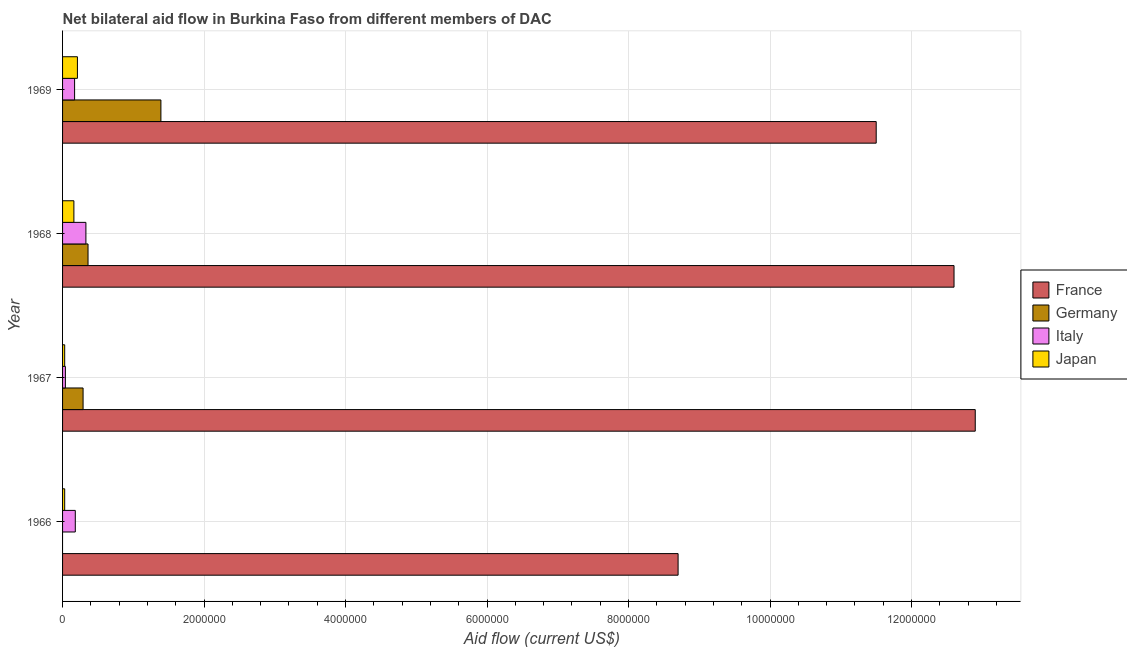How many groups of bars are there?
Your answer should be compact. 4. How many bars are there on the 4th tick from the top?
Provide a short and direct response. 3. How many bars are there on the 4th tick from the bottom?
Your answer should be compact. 4. What is the label of the 3rd group of bars from the top?
Your response must be concise. 1967. What is the amount of aid given by japan in 1966?
Make the answer very short. 3.00e+04. Across all years, what is the maximum amount of aid given by germany?
Provide a short and direct response. 1.39e+06. Across all years, what is the minimum amount of aid given by france?
Ensure brevity in your answer.  8.70e+06. In which year was the amount of aid given by italy maximum?
Provide a succinct answer. 1968. What is the total amount of aid given by japan in the graph?
Keep it short and to the point. 4.30e+05. What is the difference between the amount of aid given by france in 1967 and that in 1968?
Provide a succinct answer. 3.00e+05. What is the difference between the amount of aid given by france in 1966 and the amount of aid given by germany in 1967?
Give a very brief answer. 8.41e+06. What is the average amount of aid given by japan per year?
Ensure brevity in your answer.  1.08e+05. In the year 1966, what is the difference between the amount of aid given by italy and amount of aid given by japan?
Ensure brevity in your answer.  1.50e+05. In how many years, is the amount of aid given by italy greater than 12000000 US$?
Your answer should be compact. 0. What is the ratio of the amount of aid given by germany in 1967 to that in 1969?
Your answer should be very brief. 0.21. What is the difference between the highest and the second highest amount of aid given by italy?
Offer a terse response. 1.50e+05. What is the difference between the highest and the lowest amount of aid given by italy?
Provide a short and direct response. 2.90e+05. In how many years, is the amount of aid given by germany greater than the average amount of aid given by germany taken over all years?
Your answer should be compact. 1. Is it the case that in every year, the sum of the amount of aid given by france and amount of aid given by germany is greater than the amount of aid given by italy?
Keep it short and to the point. Yes. Are all the bars in the graph horizontal?
Provide a short and direct response. Yes. How many years are there in the graph?
Ensure brevity in your answer.  4. What is the difference between two consecutive major ticks on the X-axis?
Your answer should be compact. 2.00e+06. Does the graph contain grids?
Your answer should be compact. Yes. Where does the legend appear in the graph?
Give a very brief answer. Center right. How many legend labels are there?
Provide a succinct answer. 4. What is the title of the graph?
Offer a terse response. Net bilateral aid flow in Burkina Faso from different members of DAC. What is the label or title of the Y-axis?
Your answer should be compact. Year. What is the Aid flow (current US$) in France in 1966?
Offer a very short reply. 8.70e+06. What is the Aid flow (current US$) of Italy in 1966?
Ensure brevity in your answer.  1.80e+05. What is the Aid flow (current US$) of France in 1967?
Make the answer very short. 1.29e+07. What is the Aid flow (current US$) of Italy in 1967?
Keep it short and to the point. 4.00e+04. What is the Aid flow (current US$) in France in 1968?
Your response must be concise. 1.26e+07. What is the Aid flow (current US$) in France in 1969?
Your response must be concise. 1.15e+07. What is the Aid flow (current US$) of Germany in 1969?
Your answer should be very brief. 1.39e+06. What is the Aid flow (current US$) of Japan in 1969?
Ensure brevity in your answer.  2.10e+05. Across all years, what is the maximum Aid flow (current US$) of France?
Give a very brief answer. 1.29e+07. Across all years, what is the maximum Aid flow (current US$) of Germany?
Provide a succinct answer. 1.39e+06. Across all years, what is the maximum Aid flow (current US$) of Italy?
Offer a very short reply. 3.30e+05. Across all years, what is the maximum Aid flow (current US$) of Japan?
Give a very brief answer. 2.10e+05. Across all years, what is the minimum Aid flow (current US$) of France?
Offer a terse response. 8.70e+06. Across all years, what is the minimum Aid flow (current US$) in Germany?
Provide a succinct answer. 0. Across all years, what is the minimum Aid flow (current US$) of Italy?
Make the answer very short. 4.00e+04. What is the total Aid flow (current US$) of France in the graph?
Keep it short and to the point. 4.57e+07. What is the total Aid flow (current US$) of Germany in the graph?
Your answer should be very brief. 2.04e+06. What is the total Aid flow (current US$) in Italy in the graph?
Provide a short and direct response. 7.20e+05. What is the total Aid flow (current US$) in Japan in the graph?
Ensure brevity in your answer.  4.30e+05. What is the difference between the Aid flow (current US$) in France in 1966 and that in 1967?
Your response must be concise. -4.20e+06. What is the difference between the Aid flow (current US$) of France in 1966 and that in 1968?
Ensure brevity in your answer.  -3.90e+06. What is the difference between the Aid flow (current US$) in Italy in 1966 and that in 1968?
Your answer should be very brief. -1.50e+05. What is the difference between the Aid flow (current US$) of Japan in 1966 and that in 1968?
Offer a terse response. -1.30e+05. What is the difference between the Aid flow (current US$) of France in 1966 and that in 1969?
Your answer should be very brief. -2.80e+06. What is the difference between the Aid flow (current US$) in Japan in 1966 and that in 1969?
Provide a succinct answer. -1.80e+05. What is the difference between the Aid flow (current US$) in France in 1967 and that in 1968?
Your answer should be very brief. 3.00e+05. What is the difference between the Aid flow (current US$) in Germany in 1967 and that in 1968?
Your response must be concise. -7.00e+04. What is the difference between the Aid flow (current US$) of France in 1967 and that in 1969?
Your response must be concise. 1.40e+06. What is the difference between the Aid flow (current US$) in Germany in 1967 and that in 1969?
Offer a terse response. -1.10e+06. What is the difference between the Aid flow (current US$) of Italy in 1967 and that in 1969?
Provide a short and direct response. -1.30e+05. What is the difference between the Aid flow (current US$) in Japan in 1967 and that in 1969?
Provide a succinct answer. -1.80e+05. What is the difference between the Aid flow (current US$) in France in 1968 and that in 1969?
Keep it short and to the point. 1.10e+06. What is the difference between the Aid flow (current US$) in Germany in 1968 and that in 1969?
Keep it short and to the point. -1.03e+06. What is the difference between the Aid flow (current US$) in Italy in 1968 and that in 1969?
Provide a succinct answer. 1.60e+05. What is the difference between the Aid flow (current US$) of Japan in 1968 and that in 1969?
Make the answer very short. -5.00e+04. What is the difference between the Aid flow (current US$) in France in 1966 and the Aid flow (current US$) in Germany in 1967?
Your response must be concise. 8.41e+06. What is the difference between the Aid flow (current US$) in France in 1966 and the Aid flow (current US$) in Italy in 1967?
Your response must be concise. 8.66e+06. What is the difference between the Aid flow (current US$) in France in 1966 and the Aid flow (current US$) in Japan in 1967?
Keep it short and to the point. 8.67e+06. What is the difference between the Aid flow (current US$) of France in 1966 and the Aid flow (current US$) of Germany in 1968?
Your response must be concise. 8.34e+06. What is the difference between the Aid flow (current US$) in France in 1966 and the Aid flow (current US$) in Italy in 1968?
Offer a very short reply. 8.37e+06. What is the difference between the Aid flow (current US$) of France in 1966 and the Aid flow (current US$) of Japan in 1968?
Ensure brevity in your answer.  8.54e+06. What is the difference between the Aid flow (current US$) of France in 1966 and the Aid flow (current US$) of Germany in 1969?
Your answer should be very brief. 7.31e+06. What is the difference between the Aid flow (current US$) of France in 1966 and the Aid flow (current US$) of Italy in 1969?
Make the answer very short. 8.53e+06. What is the difference between the Aid flow (current US$) in France in 1966 and the Aid flow (current US$) in Japan in 1969?
Give a very brief answer. 8.49e+06. What is the difference between the Aid flow (current US$) of Italy in 1966 and the Aid flow (current US$) of Japan in 1969?
Make the answer very short. -3.00e+04. What is the difference between the Aid flow (current US$) in France in 1967 and the Aid flow (current US$) in Germany in 1968?
Keep it short and to the point. 1.25e+07. What is the difference between the Aid flow (current US$) of France in 1967 and the Aid flow (current US$) of Italy in 1968?
Your response must be concise. 1.26e+07. What is the difference between the Aid flow (current US$) of France in 1967 and the Aid flow (current US$) of Japan in 1968?
Offer a terse response. 1.27e+07. What is the difference between the Aid flow (current US$) of France in 1967 and the Aid flow (current US$) of Germany in 1969?
Give a very brief answer. 1.15e+07. What is the difference between the Aid flow (current US$) of France in 1967 and the Aid flow (current US$) of Italy in 1969?
Keep it short and to the point. 1.27e+07. What is the difference between the Aid flow (current US$) in France in 1967 and the Aid flow (current US$) in Japan in 1969?
Give a very brief answer. 1.27e+07. What is the difference between the Aid flow (current US$) of Germany in 1967 and the Aid flow (current US$) of Japan in 1969?
Give a very brief answer. 8.00e+04. What is the difference between the Aid flow (current US$) in Italy in 1967 and the Aid flow (current US$) in Japan in 1969?
Keep it short and to the point. -1.70e+05. What is the difference between the Aid flow (current US$) of France in 1968 and the Aid flow (current US$) of Germany in 1969?
Keep it short and to the point. 1.12e+07. What is the difference between the Aid flow (current US$) of France in 1968 and the Aid flow (current US$) of Italy in 1969?
Offer a very short reply. 1.24e+07. What is the difference between the Aid flow (current US$) in France in 1968 and the Aid flow (current US$) in Japan in 1969?
Give a very brief answer. 1.24e+07. What is the average Aid flow (current US$) of France per year?
Provide a succinct answer. 1.14e+07. What is the average Aid flow (current US$) in Germany per year?
Ensure brevity in your answer.  5.10e+05. What is the average Aid flow (current US$) in Japan per year?
Offer a very short reply. 1.08e+05. In the year 1966, what is the difference between the Aid flow (current US$) of France and Aid flow (current US$) of Italy?
Make the answer very short. 8.52e+06. In the year 1966, what is the difference between the Aid flow (current US$) of France and Aid flow (current US$) of Japan?
Ensure brevity in your answer.  8.67e+06. In the year 1967, what is the difference between the Aid flow (current US$) of France and Aid flow (current US$) of Germany?
Offer a very short reply. 1.26e+07. In the year 1967, what is the difference between the Aid flow (current US$) in France and Aid flow (current US$) in Italy?
Make the answer very short. 1.29e+07. In the year 1967, what is the difference between the Aid flow (current US$) of France and Aid flow (current US$) of Japan?
Provide a short and direct response. 1.29e+07. In the year 1967, what is the difference between the Aid flow (current US$) in Germany and Aid flow (current US$) in Japan?
Provide a succinct answer. 2.60e+05. In the year 1968, what is the difference between the Aid flow (current US$) of France and Aid flow (current US$) of Germany?
Make the answer very short. 1.22e+07. In the year 1968, what is the difference between the Aid flow (current US$) of France and Aid flow (current US$) of Italy?
Your answer should be very brief. 1.23e+07. In the year 1968, what is the difference between the Aid flow (current US$) in France and Aid flow (current US$) in Japan?
Provide a succinct answer. 1.24e+07. In the year 1968, what is the difference between the Aid flow (current US$) in Germany and Aid flow (current US$) in Italy?
Make the answer very short. 3.00e+04. In the year 1969, what is the difference between the Aid flow (current US$) of France and Aid flow (current US$) of Germany?
Offer a very short reply. 1.01e+07. In the year 1969, what is the difference between the Aid flow (current US$) in France and Aid flow (current US$) in Italy?
Provide a succinct answer. 1.13e+07. In the year 1969, what is the difference between the Aid flow (current US$) of France and Aid flow (current US$) of Japan?
Your answer should be compact. 1.13e+07. In the year 1969, what is the difference between the Aid flow (current US$) of Germany and Aid flow (current US$) of Italy?
Your answer should be compact. 1.22e+06. In the year 1969, what is the difference between the Aid flow (current US$) in Germany and Aid flow (current US$) in Japan?
Give a very brief answer. 1.18e+06. What is the ratio of the Aid flow (current US$) in France in 1966 to that in 1967?
Make the answer very short. 0.67. What is the ratio of the Aid flow (current US$) of Italy in 1966 to that in 1967?
Your answer should be compact. 4.5. What is the ratio of the Aid flow (current US$) of France in 1966 to that in 1968?
Keep it short and to the point. 0.69. What is the ratio of the Aid flow (current US$) of Italy in 1966 to that in 1968?
Provide a short and direct response. 0.55. What is the ratio of the Aid flow (current US$) in Japan in 1966 to that in 1968?
Offer a terse response. 0.19. What is the ratio of the Aid flow (current US$) of France in 1966 to that in 1969?
Make the answer very short. 0.76. What is the ratio of the Aid flow (current US$) of Italy in 1966 to that in 1969?
Your answer should be very brief. 1.06. What is the ratio of the Aid flow (current US$) in Japan in 1966 to that in 1969?
Offer a very short reply. 0.14. What is the ratio of the Aid flow (current US$) of France in 1967 to that in 1968?
Your response must be concise. 1.02. What is the ratio of the Aid flow (current US$) in Germany in 1967 to that in 1968?
Offer a very short reply. 0.81. What is the ratio of the Aid flow (current US$) of Italy in 1967 to that in 1968?
Ensure brevity in your answer.  0.12. What is the ratio of the Aid flow (current US$) of Japan in 1967 to that in 1968?
Provide a short and direct response. 0.19. What is the ratio of the Aid flow (current US$) in France in 1967 to that in 1969?
Provide a short and direct response. 1.12. What is the ratio of the Aid flow (current US$) of Germany in 1967 to that in 1969?
Keep it short and to the point. 0.21. What is the ratio of the Aid flow (current US$) in Italy in 1967 to that in 1969?
Provide a short and direct response. 0.24. What is the ratio of the Aid flow (current US$) of Japan in 1967 to that in 1969?
Your answer should be very brief. 0.14. What is the ratio of the Aid flow (current US$) in France in 1968 to that in 1969?
Your answer should be compact. 1.1. What is the ratio of the Aid flow (current US$) in Germany in 1968 to that in 1969?
Provide a succinct answer. 0.26. What is the ratio of the Aid flow (current US$) of Italy in 1968 to that in 1969?
Ensure brevity in your answer.  1.94. What is the ratio of the Aid flow (current US$) of Japan in 1968 to that in 1969?
Ensure brevity in your answer.  0.76. What is the difference between the highest and the second highest Aid flow (current US$) in France?
Provide a short and direct response. 3.00e+05. What is the difference between the highest and the second highest Aid flow (current US$) in Germany?
Ensure brevity in your answer.  1.03e+06. What is the difference between the highest and the second highest Aid flow (current US$) of Italy?
Your answer should be very brief. 1.50e+05. What is the difference between the highest and the lowest Aid flow (current US$) in France?
Provide a short and direct response. 4.20e+06. What is the difference between the highest and the lowest Aid flow (current US$) of Germany?
Your answer should be very brief. 1.39e+06. What is the difference between the highest and the lowest Aid flow (current US$) in Italy?
Keep it short and to the point. 2.90e+05. What is the difference between the highest and the lowest Aid flow (current US$) in Japan?
Give a very brief answer. 1.80e+05. 